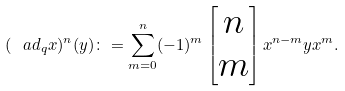<formula> <loc_0><loc_0><loc_500><loc_500>( \ a d _ { q } x ) ^ { n } ( y ) \colon = \sum _ { m = 0 } ^ { n } ( - 1 ) ^ { m } \left [ \begin{matrix} n \\ m \end{matrix} \right ] x ^ { n - m } y x ^ { m } .</formula> 